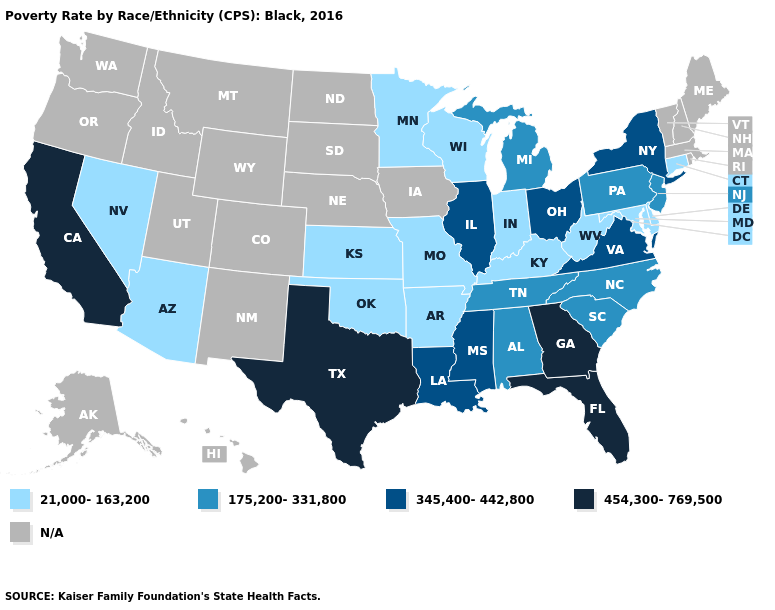What is the value of Nebraska?
Be succinct. N/A. What is the lowest value in the MidWest?
Be succinct. 21,000-163,200. Name the states that have a value in the range 21,000-163,200?
Give a very brief answer. Arizona, Arkansas, Connecticut, Delaware, Indiana, Kansas, Kentucky, Maryland, Minnesota, Missouri, Nevada, Oklahoma, West Virginia, Wisconsin. Does the first symbol in the legend represent the smallest category?
Be succinct. Yes. Which states have the highest value in the USA?
Answer briefly. California, Florida, Georgia, Texas. What is the value of New Mexico?
Concise answer only. N/A. Is the legend a continuous bar?
Concise answer only. No. What is the value of Pennsylvania?
Give a very brief answer. 175,200-331,800. Name the states that have a value in the range 21,000-163,200?
Quick response, please. Arizona, Arkansas, Connecticut, Delaware, Indiana, Kansas, Kentucky, Maryland, Minnesota, Missouri, Nevada, Oklahoma, West Virginia, Wisconsin. Among the states that border Texas , does Louisiana have the highest value?
Give a very brief answer. Yes. How many symbols are there in the legend?
Write a very short answer. 5. What is the value of Alabama?
Short answer required. 175,200-331,800. Among the states that border Connecticut , which have the lowest value?
Short answer required. New York. What is the value of Rhode Island?
Be succinct. N/A. 